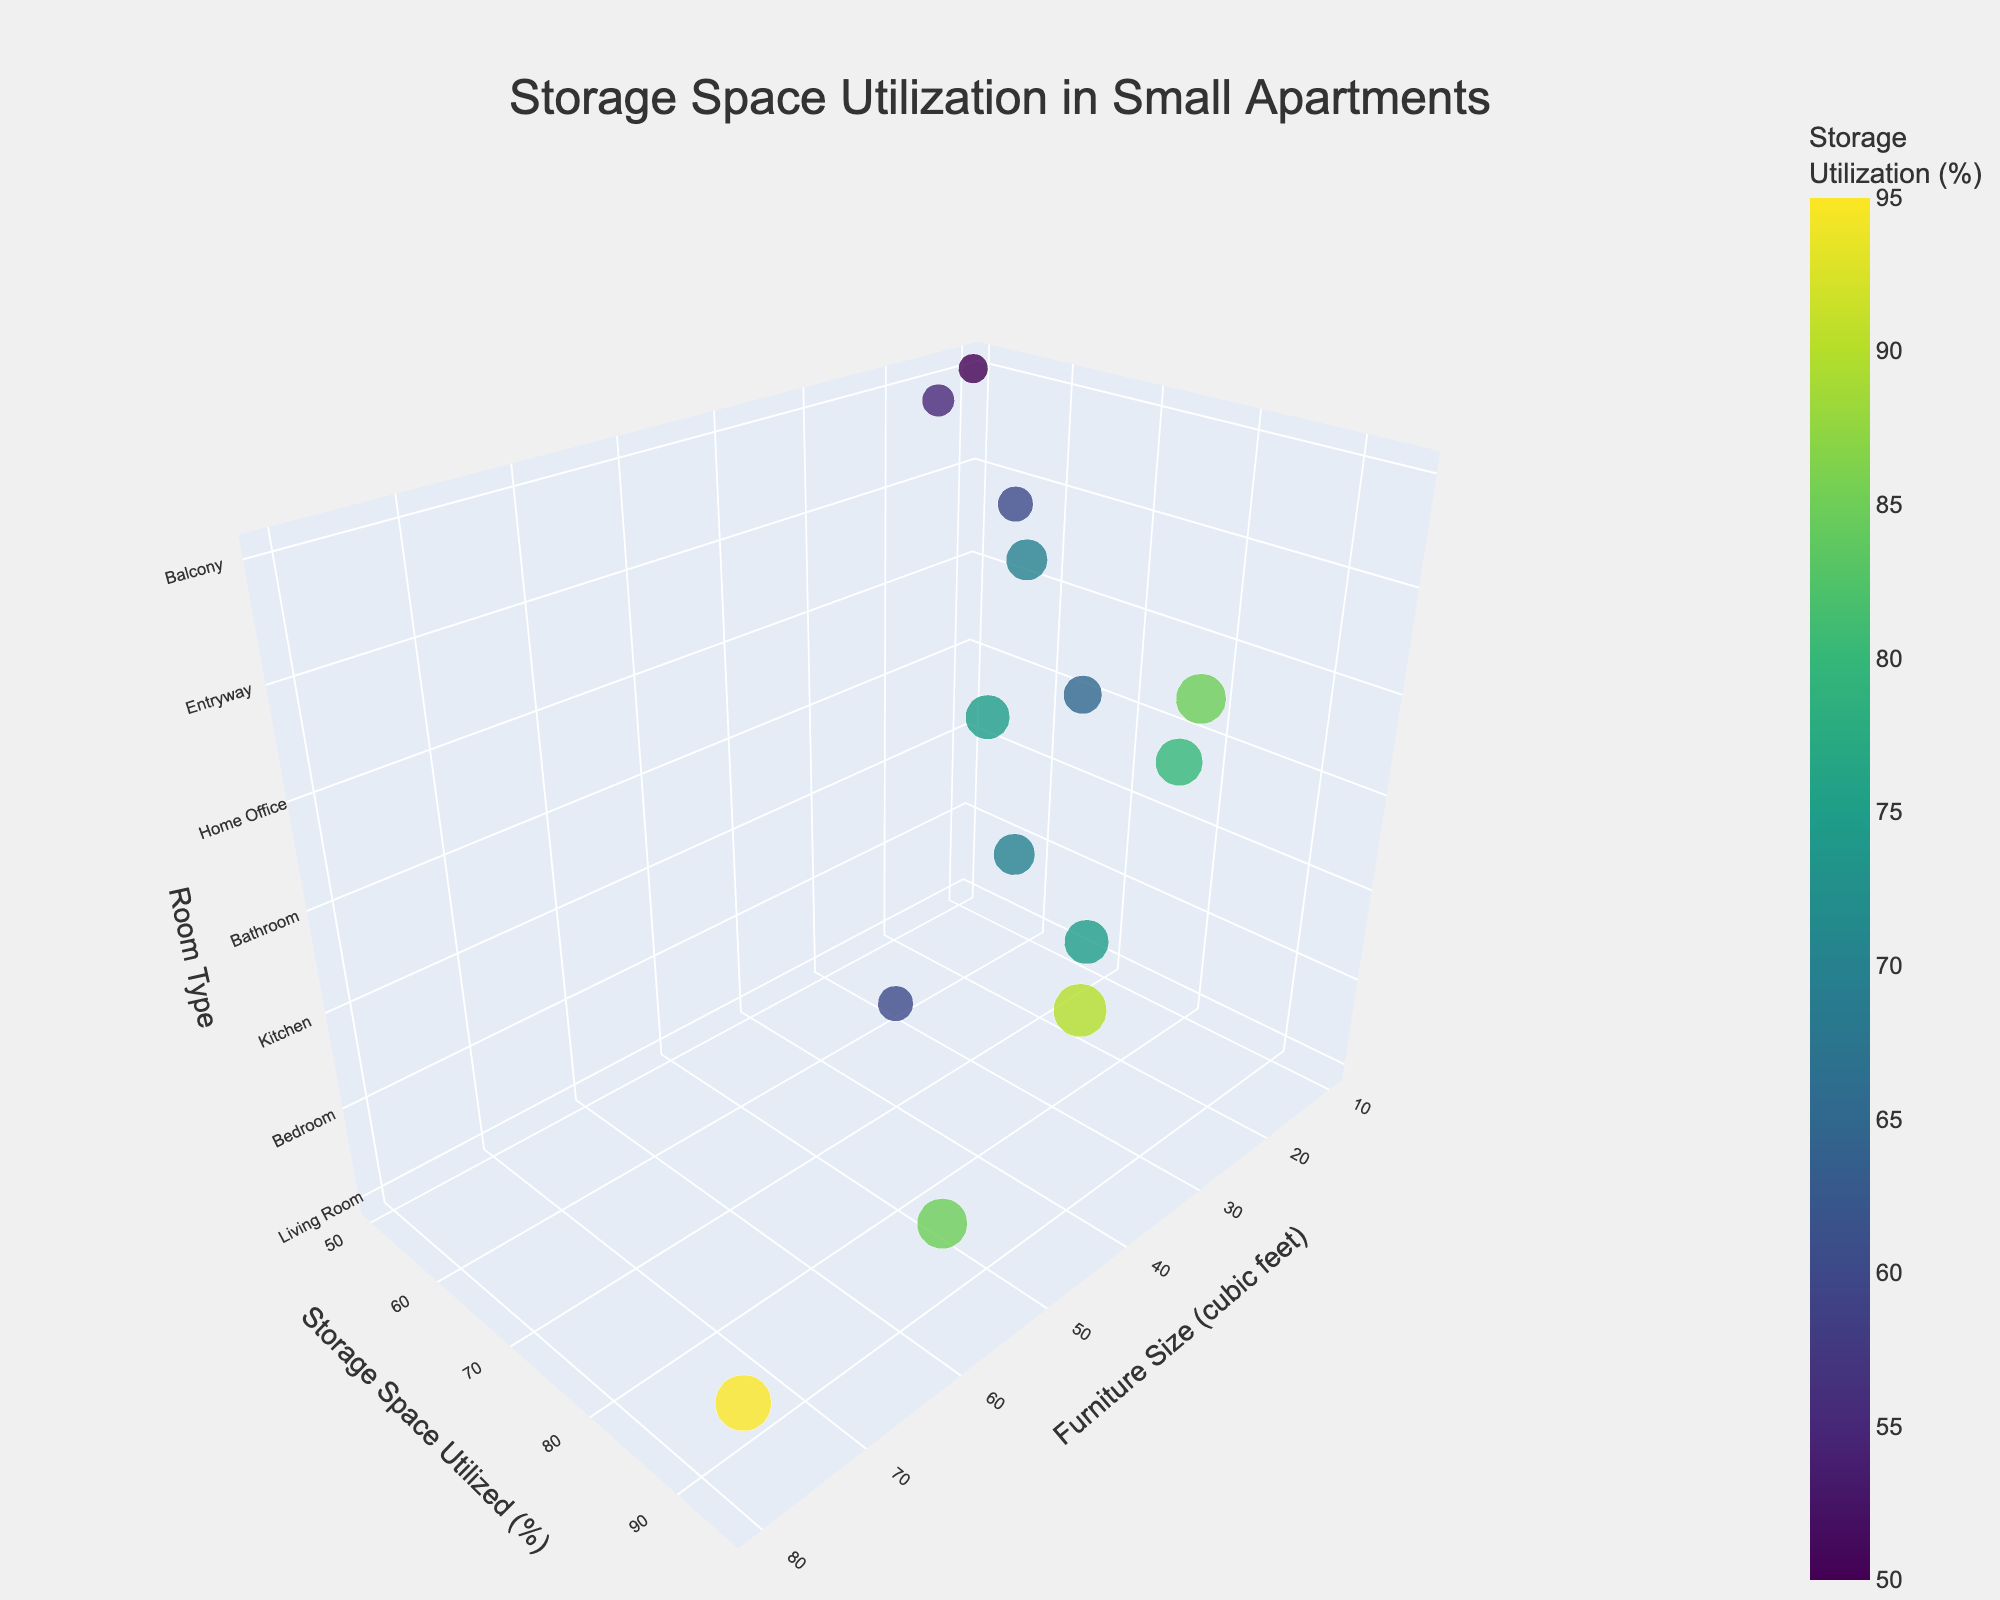what is the title of the figure? The title can be found at the top of the figure and usually describes what the plot represents. The title provides the viewers with context about the data presented in the plot.
Answer: Storage Space Utilization in Small Apartments How many different organization methods are represented in the plot? Each point in the plot represents a unique combination of furniture size, storage space utilized, room type, and organization method. By counting the unique values in the 'Organization Method' axis, we can determine the number of different methods.
Answer: 14 Which furniture piece shows the highest storage space utilization, and in which room is it located? Storage space utilization can be read on the y-axis. The highest value is 95%. By hovering over this data point, we see that it corresponds to the PAX wardrobe system in the Bedroom.
Answer: PAX wardrobe system in the Bedroom What is the average storage space utilization for furniture in the home office? To find the average, locate all the points that correspond to the 'Home Office' room type on the z-axis. Note their utilization percentages on the y-axis, add them up, and divide by the number of points. Utilizations are 75% and 85%, so (75 + 85)/2 = 80%.
Answer: 80% Which room type generally uses larger furniture pieces on average, the living room or the kitchen? Compare the average furniture sizes (cubic feet) for the living room and the kitchen. For the living room: 50 and 30, averaging (50 + 30)/2 = 40 cubic feet. For the kitchen: 40 and 25, averaging (40 + 25)/2 = 32.5 cubic feet.
Answer: Living room Is there any furniture with a storage space utilization of less than 60%? If yes, which one(s)? By examining the y-axis and identifying points below 60%, we find these pieces. The data points for 55% and 50% correspond to ÄPPLARÖ storage bench and HYLLIS shelving unit, respectively.
Answer: Yes, ÄPPLARÖ storage bench and HYLLIS shelving unit Which organization method in the bathroom provides the most efficient usage of storage space? In the bathroom, compare the storage space utilization percentages of the GODMORGON sink cabinet and the LILLÅNGEN mirror cabinet, and find the higher one, which is 80% for the GODMORGON sink cabinet.
Answer: GODMORGON sink cabinet What is the relationship between furniture size and storage space utilized in the entryway? Locate the entryway points on the z-axis and analyze their positions along the x (furniture size) and y (storage space utilized) axes. Both HEMNES shoe cabinet (25 cubic feet, 70%) and TRONES shoe cabinet (15 cubic feet, 60%) suggest a positive correlation as the small decrease in furniture size slightly reduces utilization.
Answer: Positive correlation What furniture item gives the least storage space utilization in the home office? Examine the points representing the home office and compare the storage utilization percentages. The MICKE desk with storage has 75%, and the ALEX drawer unit has 85%. The MICKE desk with storage has the least utilization.
Answer: MICKE desk with storage Which room type appears most frequently in the plot based on the number of related data points? Count the number of points related to each room type by identifying their positions on the z-axis. The room type with the highest count of data points is the one that appears most frequently. The home office and living room both appear with 2 data points each, so they are the most frequent.
Answer: Home office and Living room 